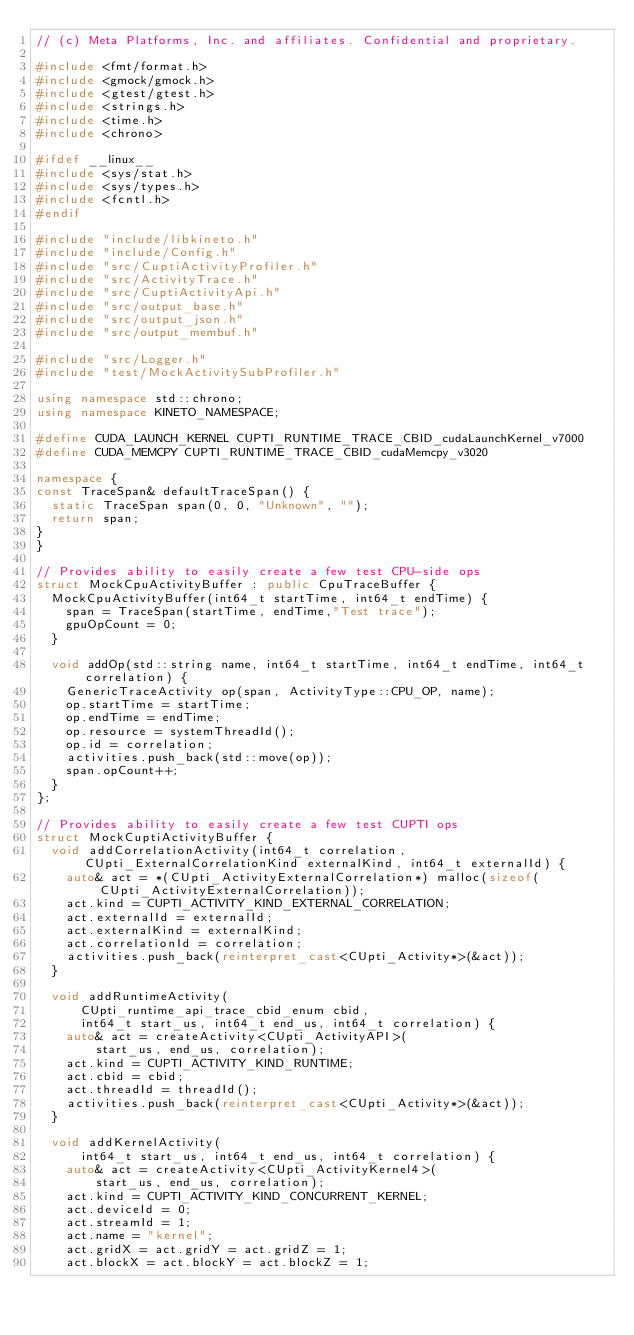<code> <loc_0><loc_0><loc_500><loc_500><_C++_>// (c) Meta Platforms, Inc. and affiliates. Confidential and proprietary.

#include <fmt/format.h>
#include <gmock/gmock.h>
#include <gtest/gtest.h>
#include <strings.h>
#include <time.h>
#include <chrono>

#ifdef __linux__
#include <sys/stat.h>
#include <sys/types.h>
#include <fcntl.h>
#endif

#include "include/libkineto.h"
#include "include/Config.h"
#include "src/CuptiActivityProfiler.h"
#include "src/ActivityTrace.h"
#include "src/CuptiActivityApi.h"
#include "src/output_base.h"
#include "src/output_json.h"
#include "src/output_membuf.h"

#include "src/Logger.h"
#include "test/MockActivitySubProfiler.h"

using namespace std::chrono;
using namespace KINETO_NAMESPACE;

#define CUDA_LAUNCH_KERNEL CUPTI_RUNTIME_TRACE_CBID_cudaLaunchKernel_v7000
#define CUDA_MEMCPY CUPTI_RUNTIME_TRACE_CBID_cudaMemcpy_v3020

namespace {
const TraceSpan& defaultTraceSpan() {
  static TraceSpan span(0, 0, "Unknown", "");
  return span;
}
}

// Provides ability to easily create a few test CPU-side ops
struct MockCpuActivityBuffer : public CpuTraceBuffer {
  MockCpuActivityBuffer(int64_t startTime, int64_t endTime) {
    span = TraceSpan(startTime, endTime,"Test trace");
    gpuOpCount = 0;
  }

  void addOp(std::string name, int64_t startTime, int64_t endTime, int64_t correlation) {
    GenericTraceActivity op(span, ActivityType::CPU_OP, name);
    op.startTime = startTime;
    op.endTime = endTime;
    op.resource = systemThreadId();
    op.id = correlation;
    activities.push_back(std::move(op));
    span.opCount++;
  }
};

// Provides ability to easily create a few test CUPTI ops
struct MockCuptiActivityBuffer {
  void addCorrelationActivity(int64_t correlation, CUpti_ExternalCorrelationKind externalKind, int64_t externalId) {
    auto& act = *(CUpti_ActivityExternalCorrelation*) malloc(sizeof(CUpti_ActivityExternalCorrelation));
    act.kind = CUPTI_ACTIVITY_KIND_EXTERNAL_CORRELATION;
    act.externalId = externalId;
    act.externalKind = externalKind;
    act.correlationId = correlation;
    activities.push_back(reinterpret_cast<CUpti_Activity*>(&act));
  }

  void addRuntimeActivity(
      CUpti_runtime_api_trace_cbid_enum cbid,
      int64_t start_us, int64_t end_us, int64_t correlation) {
    auto& act = createActivity<CUpti_ActivityAPI>(
        start_us, end_us, correlation);
    act.kind = CUPTI_ACTIVITY_KIND_RUNTIME;
    act.cbid = cbid;
    act.threadId = threadId();
    activities.push_back(reinterpret_cast<CUpti_Activity*>(&act));
  }

  void addKernelActivity(
      int64_t start_us, int64_t end_us, int64_t correlation) {
    auto& act = createActivity<CUpti_ActivityKernel4>(
        start_us, end_us, correlation);
    act.kind = CUPTI_ACTIVITY_KIND_CONCURRENT_KERNEL;
    act.deviceId = 0;
    act.streamId = 1;
    act.name = "kernel";
    act.gridX = act.gridY = act.gridZ = 1;
    act.blockX = act.blockY = act.blockZ = 1;</code> 